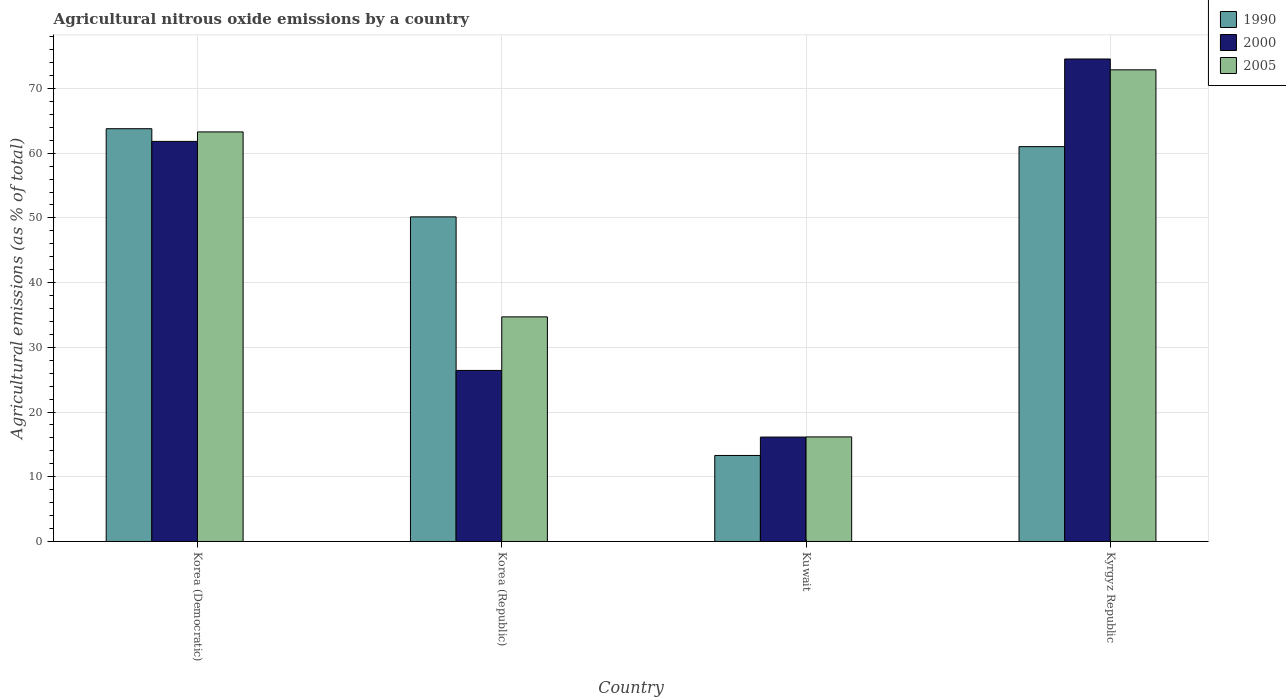How many different coloured bars are there?
Provide a succinct answer. 3. How many groups of bars are there?
Offer a very short reply. 4. Are the number of bars per tick equal to the number of legend labels?
Your response must be concise. Yes. What is the label of the 1st group of bars from the left?
Your response must be concise. Korea (Democratic). What is the amount of agricultural nitrous oxide emitted in 1990 in Kyrgyz Republic?
Make the answer very short. 61.01. Across all countries, what is the maximum amount of agricultural nitrous oxide emitted in 2005?
Provide a short and direct response. 72.88. Across all countries, what is the minimum amount of agricultural nitrous oxide emitted in 2000?
Provide a short and direct response. 16.13. In which country was the amount of agricultural nitrous oxide emitted in 2005 maximum?
Provide a short and direct response. Kyrgyz Republic. In which country was the amount of agricultural nitrous oxide emitted in 2005 minimum?
Your answer should be very brief. Kuwait. What is the total amount of agricultural nitrous oxide emitted in 2005 in the graph?
Provide a succinct answer. 187.04. What is the difference between the amount of agricultural nitrous oxide emitted in 1990 in Korea (Republic) and that in Kuwait?
Give a very brief answer. 36.87. What is the difference between the amount of agricultural nitrous oxide emitted in 1990 in Korea (Republic) and the amount of agricultural nitrous oxide emitted in 2000 in Kuwait?
Provide a short and direct response. 34.03. What is the average amount of agricultural nitrous oxide emitted in 1990 per country?
Provide a succinct answer. 47.06. What is the difference between the amount of agricultural nitrous oxide emitted of/in 2000 and amount of agricultural nitrous oxide emitted of/in 1990 in Korea (Democratic)?
Ensure brevity in your answer.  -1.96. In how many countries, is the amount of agricultural nitrous oxide emitted in 1990 greater than 42 %?
Keep it short and to the point. 3. What is the ratio of the amount of agricultural nitrous oxide emitted in 2000 in Korea (Democratic) to that in Korea (Republic)?
Provide a succinct answer. 2.34. What is the difference between the highest and the second highest amount of agricultural nitrous oxide emitted in 1990?
Your answer should be compact. -10.86. What is the difference between the highest and the lowest amount of agricultural nitrous oxide emitted in 2000?
Give a very brief answer. 58.42. What does the 3rd bar from the left in Korea (Democratic) represents?
Keep it short and to the point. 2005. Is it the case that in every country, the sum of the amount of agricultural nitrous oxide emitted in 2000 and amount of agricultural nitrous oxide emitted in 1990 is greater than the amount of agricultural nitrous oxide emitted in 2005?
Provide a short and direct response. Yes. Does the graph contain grids?
Your response must be concise. Yes. Where does the legend appear in the graph?
Give a very brief answer. Top right. How many legend labels are there?
Provide a short and direct response. 3. What is the title of the graph?
Make the answer very short. Agricultural nitrous oxide emissions by a country. Does "2010" appear as one of the legend labels in the graph?
Your answer should be compact. No. What is the label or title of the X-axis?
Offer a terse response. Country. What is the label or title of the Y-axis?
Your answer should be very brief. Agricultural emissions (as % of total). What is the Agricultural emissions (as % of total) in 1990 in Korea (Democratic)?
Your answer should be very brief. 63.78. What is the Agricultural emissions (as % of total) of 2000 in Korea (Democratic)?
Offer a terse response. 61.82. What is the Agricultural emissions (as % of total) of 2005 in Korea (Democratic)?
Provide a succinct answer. 63.29. What is the Agricultural emissions (as % of total) of 1990 in Korea (Republic)?
Your answer should be compact. 50.16. What is the Agricultural emissions (as % of total) of 2000 in Korea (Republic)?
Keep it short and to the point. 26.43. What is the Agricultural emissions (as % of total) of 2005 in Korea (Republic)?
Give a very brief answer. 34.71. What is the Agricultural emissions (as % of total) in 1990 in Kuwait?
Ensure brevity in your answer.  13.29. What is the Agricultural emissions (as % of total) of 2000 in Kuwait?
Provide a succinct answer. 16.13. What is the Agricultural emissions (as % of total) in 2005 in Kuwait?
Give a very brief answer. 16.16. What is the Agricultural emissions (as % of total) of 1990 in Kyrgyz Republic?
Keep it short and to the point. 61.01. What is the Agricultural emissions (as % of total) in 2000 in Kyrgyz Republic?
Provide a short and direct response. 74.56. What is the Agricultural emissions (as % of total) in 2005 in Kyrgyz Republic?
Provide a short and direct response. 72.88. Across all countries, what is the maximum Agricultural emissions (as % of total) of 1990?
Keep it short and to the point. 63.78. Across all countries, what is the maximum Agricultural emissions (as % of total) in 2000?
Your response must be concise. 74.56. Across all countries, what is the maximum Agricultural emissions (as % of total) in 2005?
Give a very brief answer. 72.88. Across all countries, what is the minimum Agricultural emissions (as % of total) of 1990?
Your answer should be very brief. 13.29. Across all countries, what is the minimum Agricultural emissions (as % of total) of 2000?
Offer a terse response. 16.13. Across all countries, what is the minimum Agricultural emissions (as % of total) in 2005?
Keep it short and to the point. 16.16. What is the total Agricultural emissions (as % of total) of 1990 in the graph?
Your answer should be compact. 188.25. What is the total Agricultural emissions (as % of total) of 2000 in the graph?
Your answer should be very brief. 178.95. What is the total Agricultural emissions (as % of total) in 2005 in the graph?
Ensure brevity in your answer.  187.04. What is the difference between the Agricultural emissions (as % of total) of 1990 in Korea (Democratic) and that in Korea (Republic)?
Offer a terse response. 13.62. What is the difference between the Agricultural emissions (as % of total) in 2000 in Korea (Democratic) and that in Korea (Republic)?
Provide a succinct answer. 35.39. What is the difference between the Agricultural emissions (as % of total) in 2005 in Korea (Democratic) and that in Korea (Republic)?
Ensure brevity in your answer.  28.58. What is the difference between the Agricultural emissions (as % of total) of 1990 in Korea (Democratic) and that in Kuwait?
Offer a very short reply. 50.49. What is the difference between the Agricultural emissions (as % of total) in 2000 in Korea (Democratic) and that in Kuwait?
Make the answer very short. 45.69. What is the difference between the Agricultural emissions (as % of total) of 2005 in Korea (Democratic) and that in Kuwait?
Keep it short and to the point. 47.13. What is the difference between the Agricultural emissions (as % of total) in 1990 in Korea (Democratic) and that in Kyrgyz Republic?
Offer a very short reply. 2.77. What is the difference between the Agricultural emissions (as % of total) in 2000 in Korea (Democratic) and that in Kyrgyz Republic?
Your answer should be compact. -12.73. What is the difference between the Agricultural emissions (as % of total) in 2005 in Korea (Democratic) and that in Kyrgyz Republic?
Your response must be concise. -9.6. What is the difference between the Agricultural emissions (as % of total) in 1990 in Korea (Republic) and that in Kuwait?
Your answer should be very brief. 36.87. What is the difference between the Agricultural emissions (as % of total) in 2000 in Korea (Republic) and that in Kuwait?
Offer a very short reply. 10.3. What is the difference between the Agricultural emissions (as % of total) in 2005 in Korea (Republic) and that in Kuwait?
Give a very brief answer. 18.55. What is the difference between the Agricultural emissions (as % of total) in 1990 in Korea (Republic) and that in Kyrgyz Republic?
Provide a succinct answer. -10.86. What is the difference between the Agricultural emissions (as % of total) of 2000 in Korea (Republic) and that in Kyrgyz Republic?
Keep it short and to the point. -48.12. What is the difference between the Agricultural emissions (as % of total) of 2005 in Korea (Republic) and that in Kyrgyz Republic?
Your response must be concise. -38.18. What is the difference between the Agricultural emissions (as % of total) in 1990 in Kuwait and that in Kyrgyz Republic?
Offer a terse response. -47.72. What is the difference between the Agricultural emissions (as % of total) of 2000 in Kuwait and that in Kyrgyz Republic?
Your response must be concise. -58.42. What is the difference between the Agricultural emissions (as % of total) in 2005 in Kuwait and that in Kyrgyz Republic?
Your response must be concise. -56.73. What is the difference between the Agricultural emissions (as % of total) in 1990 in Korea (Democratic) and the Agricultural emissions (as % of total) in 2000 in Korea (Republic)?
Keep it short and to the point. 37.35. What is the difference between the Agricultural emissions (as % of total) of 1990 in Korea (Democratic) and the Agricultural emissions (as % of total) of 2005 in Korea (Republic)?
Provide a short and direct response. 29.08. What is the difference between the Agricultural emissions (as % of total) in 2000 in Korea (Democratic) and the Agricultural emissions (as % of total) in 2005 in Korea (Republic)?
Provide a short and direct response. 27.11. What is the difference between the Agricultural emissions (as % of total) of 1990 in Korea (Democratic) and the Agricultural emissions (as % of total) of 2000 in Kuwait?
Offer a terse response. 47.65. What is the difference between the Agricultural emissions (as % of total) of 1990 in Korea (Democratic) and the Agricultural emissions (as % of total) of 2005 in Kuwait?
Offer a terse response. 47.63. What is the difference between the Agricultural emissions (as % of total) in 2000 in Korea (Democratic) and the Agricultural emissions (as % of total) in 2005 in Kuwait?
Provide a succinct answer. 45.66. What is the difference between the Agricultural emissions (as % of total) in 1990 in Korea (Democratic) and the Agricultural emissions (as % of total) in 2000 in Kyrgyz Republic?
Provide a short and direct response. -10.77. What is the difference between the Agricultural emissions (as % of total) in 1990 in Korea (Democratic) and the Agricultural emissions (as % of total) in 2005 in Kyrgyz Republic?
Keep it short and to the point. -9.1. What is the difference between the Agricultural emissions (as % of total) of 2000 in Korea (Democratic) and the Agricultural emissions (as % of total) of 2005 in Kyrgyz Republic?
Offer a terse response. -11.06. What is the difference between the Agricultural emissions (as % of total) in 1990 in Korea (Republic) and the Agricultural emissions (as % of total) in 2000 in Kuwait?
Provide a short and direct response. 34.03. What is the difference between the Agricultural emissions (as % of total) in 1990 in Korea (Republic) and the Agricultural emissions (as % of total) in 2005 in Kuwait?
Make the answer very short. 34. What is the difference between the Agricultural emissions (as % of total) in 2000 in Korea (Republic) and the Agricultural emissions (as % of total) in 2005 in Kuwait?
Ensure brevity in your answer.  10.27. What is the difference between the Agricultural emissions (as % of total) in 1990 in Korea (Republic) and the Agricultural emissions (as % of total) in 2000 in Kyrgyz Republic?
Your answer should be very brief. -24.4. What is the difference between the Agricultural emissions (as % of total) of 1990 in Korea (Republic) and the Agricultural emissions (as % of total) of 2005 in Kyrgyz Republic?
Your answer should be very brief. -22.72. What is the difference between the Agricultural emissions (as % of total) in 2000 in Korea (Republic) and the Agricultural emissions (as % of total) in 2005 in Kyrgyz Republic?
Make the answer very short. -46.45. What is the difference between the Agricultural emissions (as % of total) of 1990 in Kuwait and the Agricultural emissions (as % of total) of 2000 in Kyrgyz Republic?
Give a very brief answer. -61.26. What is the difference between the Agricultural emissions (as % of total) of 1990 in Kuwait and the Agricultural emissions (as % of total) of 2005 in Kyrgyz Republic?
Offer a very short reply. -59.59. What is the difference between the Agricultural emissions (as % of total) in 2000 in Kuwait and the Agricultural emissions (as % of total) in 2005 in Kyrgyz Republic?
Your response must be concise. -56.75. What is the average Agricultural emissions (as % of total) of 1990 per country?
Give a very brief answer. 47.06. What is the average Agricultural emissions (as % of total) of 2000 per country?
Make the answer very short. 44.74. What is the average Agricultural emissions (as % of total) in 2005 per country?
Ensure brevity in your answer.  46.76. What is the difference between the Agricultural emissions (as % of total) in 1990 and Agricultural emissions (as % of total) in 2000 in Korea (Democratic)?
Offer a very short reply. 1.96. What is the difference between the Agricultural emissions (as % of total) in 1990 and Agricultural emissions (as % of total) in 2005 in Korea (Democratic)?
Give a very brief answer. 0.5. What is the difference between the Agricultural emissions (as % of total) of 2000 and Agricultural emissions (as % of total) of 2005 in Korea (Democratic)?
Provide a succinct answer. -1.47. What is the difference between the Agricultural emissions (as % of total) in 1990 and Agricultural emissions (as % of total) in 2000 in Korea (Republic)?
Ensure brevity in your answer.  23.73. What is the difference between the Agricultural emissions (as % of total) of 1990 and Agricultural emissions (as % of total) of 2005 in Korea (Republic)?
Provide a short and direct response. 15.45. What is the difference between the Agricultural emissions (as % of total) of 2000 and Agricultural emissions (as % of total) of 2005 in Korea (Republic)?
Give a very brief answer. -8.28. What is the difference between the Agricultural emissions (as % of total) of 1990 and Agricultural emissions (as % of total) of 2000 in Kuwait?
Keep it short and to the point. -2.84. What is the difference between the Agricultural emissions (as % of total) in 1990 and Agricultural emissions (as % of total) in 2005 in Kuwait?
Give a very brief answer. -2.87. What is the difference between the Agricultural emissions (as % of total) of 2000 and Agricultural emissions (as % of total) of 2005 in Kuwait?
Your answer should be very brief. -0.02. What is the difference between the Agricultural emissions (as % of total) in 1990 and Agricultural emissions (as % of total) in 2000 in Kyrgyz Republic?
Offer a terse response. -13.54. What is the difference between the Agricultural emissions (as % of total) in 1990 and Agricultural emissions (as % of total) in 2005 in Kyrgyz Republic?
Provide a succinct answer. -11.87. What is the difference between the Agricultural emissions (as % of total) of 2000 and Agricultural emissions (as % of total) of 2005 in Kyrgyz Republic?
Keep it short and to the point. 1.67. What is the ratio of the Agricultural emissions (as % of total) of 1990 in Korea (Democratic) to that in Korea (Republic)?
Offer a very short reply. 1.27. What is the ratio of the Agricultural emissions (as % of total) of 2000 in Korea (Democratic) to that in Korea (Republic)?
Provide a short and direct response. 2.34. What is the ratio of the Agricultural emissions (as % of total) in 2005 in Korea (Democratic) to that in Korea (Republic)?
Your answer should be compact. 1.82. What is the ratio of the Agricultural emissions (as % of total) of 1990 in Korea (Democratic) to that in Kuwait?
Provide a short and direct response. 4.8. What is the ratio of the Agricultural emissions (as % of total) of 2000 in Korea (Democratic) to that in Kuwait?
Ensure brevity in your answer.  3.83. What is the ratio of the Agricultural emissions (as % of total) in 2005 in Korea (Democratic) to that in Kuwait?
Your answer should be compact. 3.92. What is the ratio of the Agricultural emissions (as % of total) of 1990 in Korea (Democratic) to that in Kyrgyz Republic?
Your response must be concise. 1.05. What is the ratio of the Agricultural emissions (as % of total) of 2000 in Korea (Democratic) to that in Kyrgyz Republic?
Offer a terse response. 0.83. What is the ratio of the Agricultural emissions (as % of total) in 2005 in Korea (Democratic) to that in Kyrgyz Republic?
Provide a short and direct response. 0.87. What is the ratio of the Agricultural emissions (as % of total) of 1990 in Korea (Republic) to that in Kuwait?
Your answer should be very brief. 3.77. What is the ratio of the Agricultural emissions (as % of total) in 2000 in Korea (Republic) to that in Kuwait?
Ensure brevity in your answer.  1.64. What is the ratio of the Agricultural emissions (as % of total) of 2005 in Korea (Republic) to that in Kuwait?
Your answer should be very brief. 2.15. What is the ratio of the Agricultural emissions (as % of total) in 1990 in Korea (Republic) to that in Kyrgyz Republic?
Make the answer very short. 0.82. What is the ratio of the Agricultural emissions (as % of total) in 2000 in Korea (Republic) to that in Kyrgyz Republic?
Give a very brief answer. 0.35. What is the ratio of the Agricultural emissions (as % of total) of 2005 in Korea (Republic) to that in Kyrgyz Republic?
Ensure brevity in your answer.  0.48. What is the ratio of the Agricultural emissions (as % of total) of 1990 in Kuwait to that in Kyrgyz Republic?
Your response must be concise. 0.22. What is the ratio of the Agricultural emissions (as % of total) in 2000 in Kuwait to that in Kyrgyz Republic?
Provide a succinct answer. 0.22. What is the ratio of the Agricultural emissions (as % of total) in 2005 in Kuwait to that in Kyrgyz Republic?
Your answer should be compact. 0.22. What is the difference between the highest and the second highest Agricultural emissions (as % of total) in 1990?
Provide a succinct answer. 2.77. What is the difference between the highest and the second highest Agricultural emissions (as % of total) of 2000?
Your answer should be compact. 12.73. What is the difference between the highest and the second highest Agricultural emissions (as % of total) of 2005?
Give a very brief answer. 9.6. What is the difference between the highest and the lowest Agricultural emissions (as % of total) of 1990?
Your response must be concise. 50.49. What is the difference between the highest and the lowest Agricultural emissions (as % of total) of 2000?
Give a very brief answer. 58.42. What is the difference between the highest and the lowest Agricultural emissions (as % of total) in 2005?
Give a very brief answer. 56.73. 